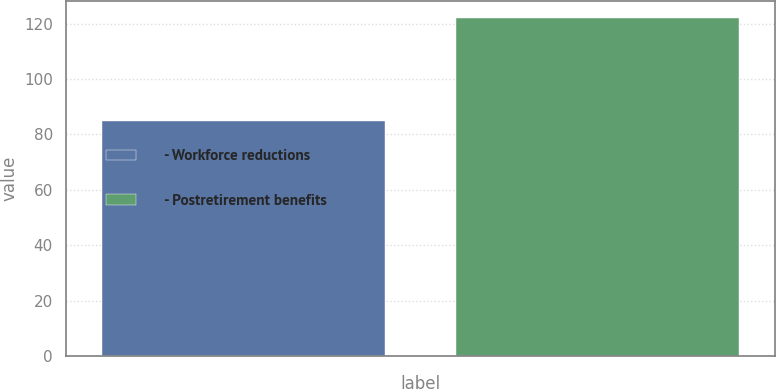Convert chart to OTSL. <chart><loc_0><loc_0><loc_500><loc_500><bar_chart><fcel>- Workforce reductions<fcel>- Postretirement benefits<nl><fcel>85<fcel>122<nl></chart> 